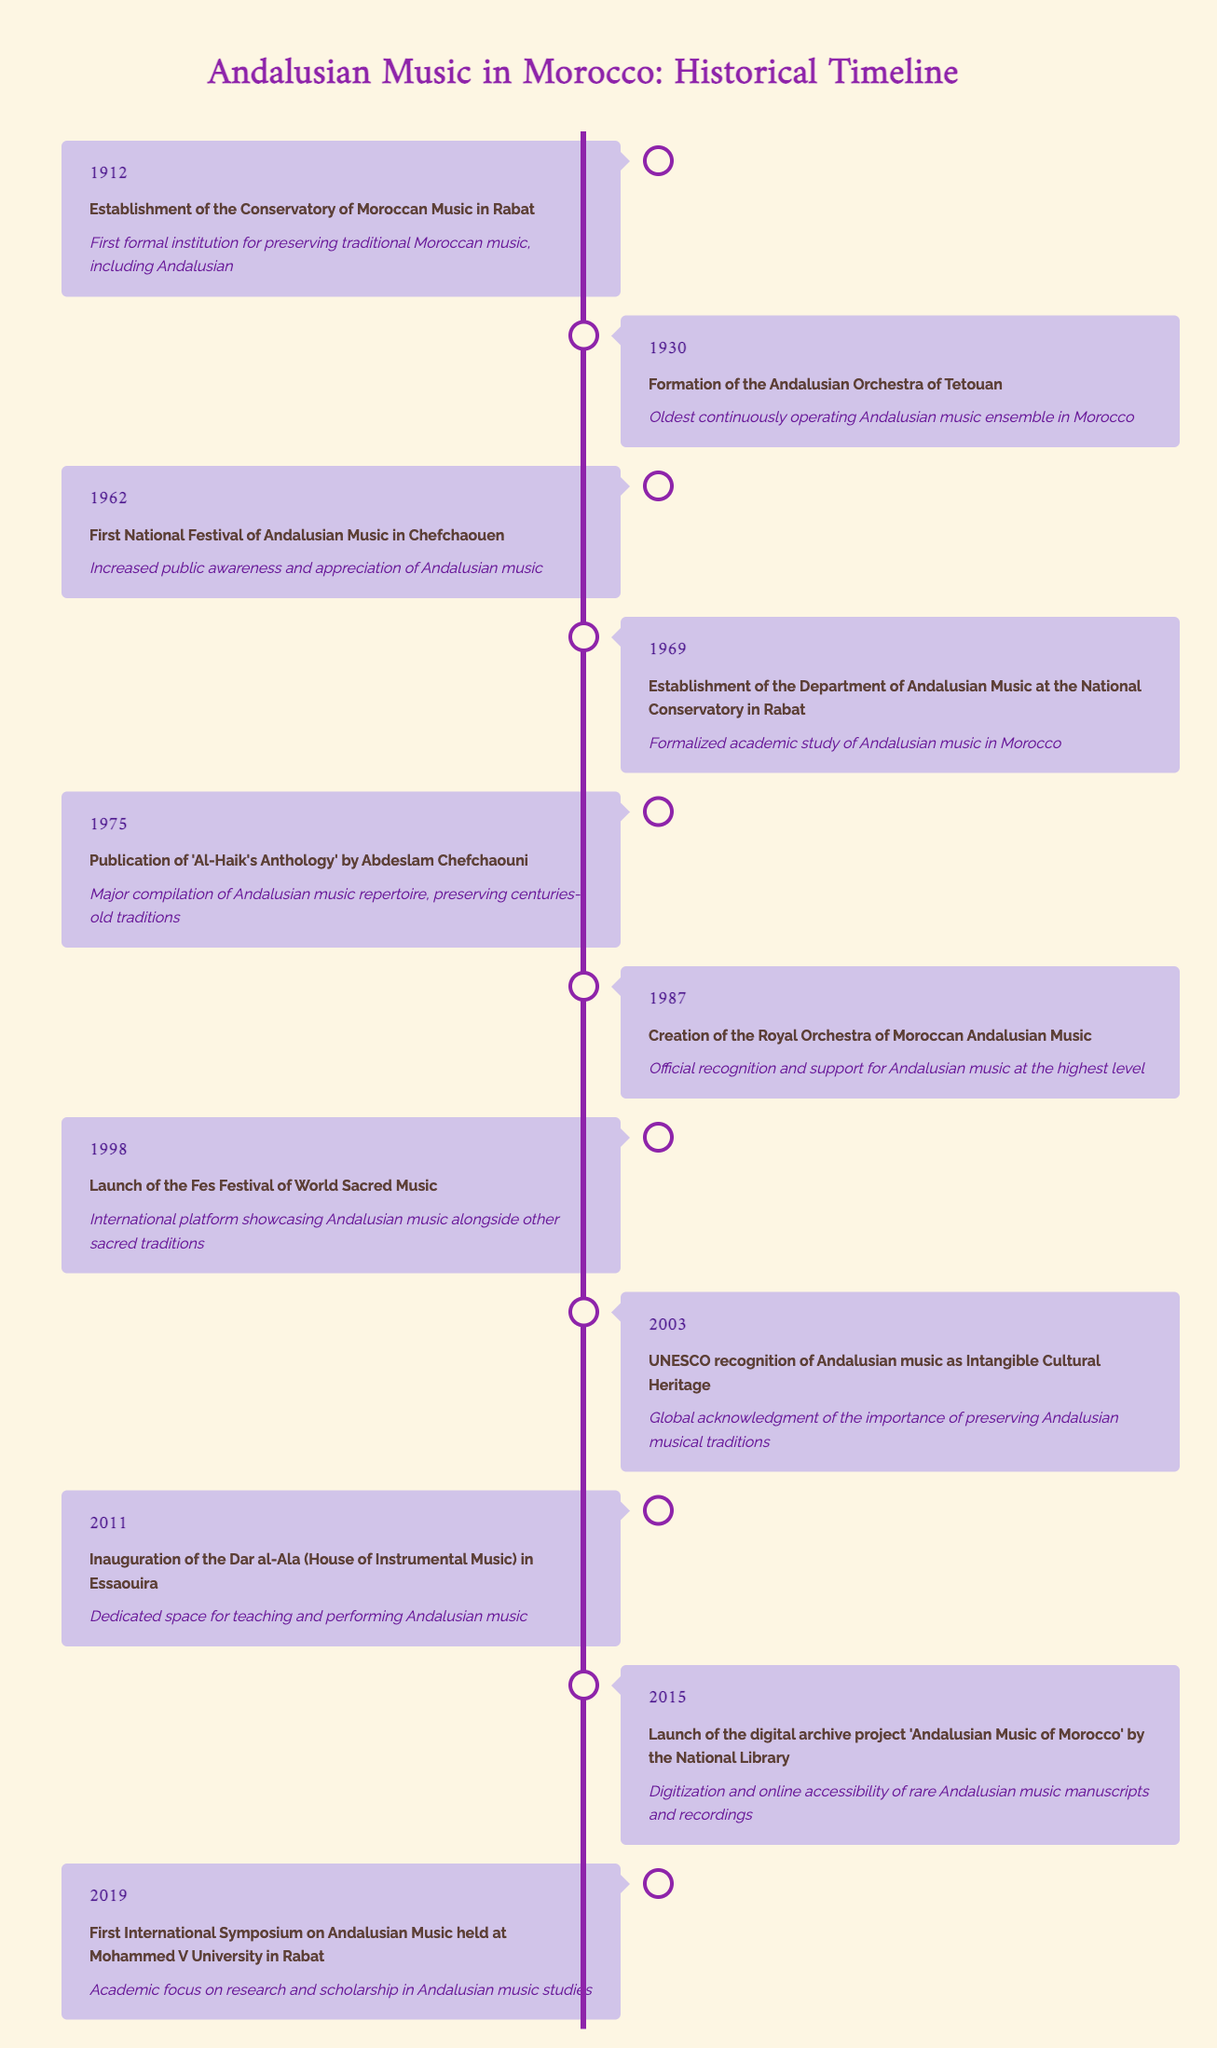What year was the first National Festival of Andalusian Music held? The first National Festival of Andalusian Music occurred in Chefchaouen in 1962 according to the table. Therefore, the answer is 1962.
Answer: 1962 What was established in 1975 and what was its significance? In 1975, 'Al-Haik's Anthology' was published by Abdeslam Chefchaouni. Its significance is that it is a major compilation of the Andalusian music repertoire, preserving centuries-old traditions.
Answer: 'Al-Haik's Anthology' Is it true that the Royal Orchestra of Moroccan Andalusian Music was created before the UNESCO recognition? The Royal Orchestra of Moroccan Andalusian Music was created in 1987, and UNESCO recognized Andalusian music in 2003. Since 1987 is before 2003, the statement is true.
Answer: Yes Which event marks the formal academic study of Andalusian music in Morocco and when did it happen? The establishment of the Department of Andalusian Music at the National Conservatory in Rabat in 1969 marks the formal academic study of Andalusian music in Morocco.
Answer: 1969 How many years passed between the establishment of the Conservatory of Moroccan Music and the formation of the Andalusian Orchestra of Tetouan? The Conservatory of Moroccan Music was established in 1912, and the Andalusian Orchestra of Tetouan was formed in 1930. The difference is 1930 - 1912 = 18 years.
Answer: 18 years What are the two significant events that took place in 2011? In 2011, two significant events occurred: the inauguration of the Dar al-Ala (House of Instrumental Music) in Essaouira, which provides a dedicated space for teaching and performing Andalusian music, and the launch of the digital archive project 'Andalusian Music of Morocco'.
Answer: Not applicable (two events) How many milestones listed in the table took place in the 20th century? The events from the table that took place in the 20th century are 1912, 1930, 1962, 1969, 1975, 1987, and 1998. Counting these gives a total of 7 milestones.
Answer: 7 What was the purpose of the Fes Festival of World Sacred Music that started in 1998? The purpose of the Fes Festival of World Sacred Music launched in 1998 was to provide an international platform to showcase Andalusian music alongside other sacred traditions.
Answer: Showcase music In what year did the first International Symposium on Andalusian Music occur? The first International Symposium on Andalusian Music occurred in 2019 according to the table.
Answer: 2019 